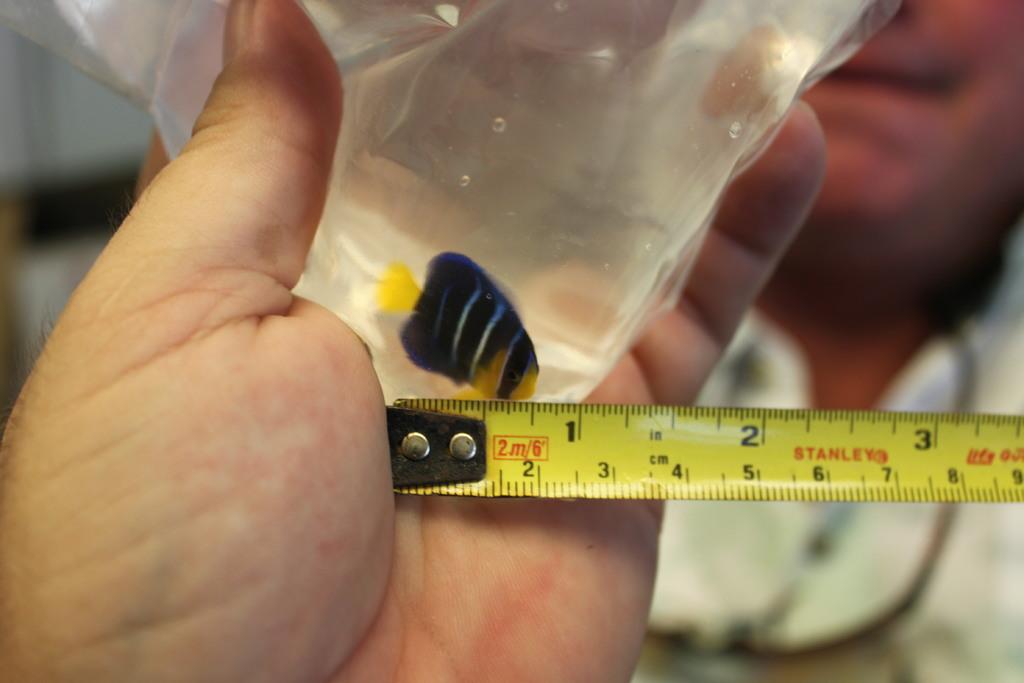How large is the fish?
Offer a terse response. 1 inch. What brand of measuring tape is this?
Offer a very short reply. Stanley. 